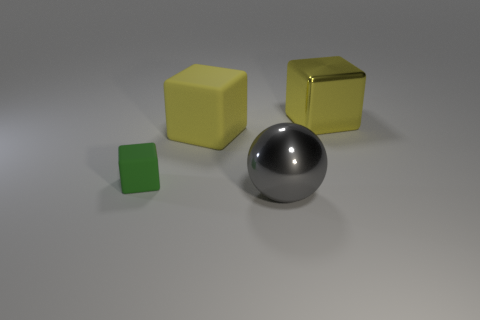What material do the objects appear to be made from? The cubes seem to have a metallic finish, likely indicating that they're made of a type of metal, while the spherical object appears to be reflective and could be made of polished metal or a metallic alloy. 